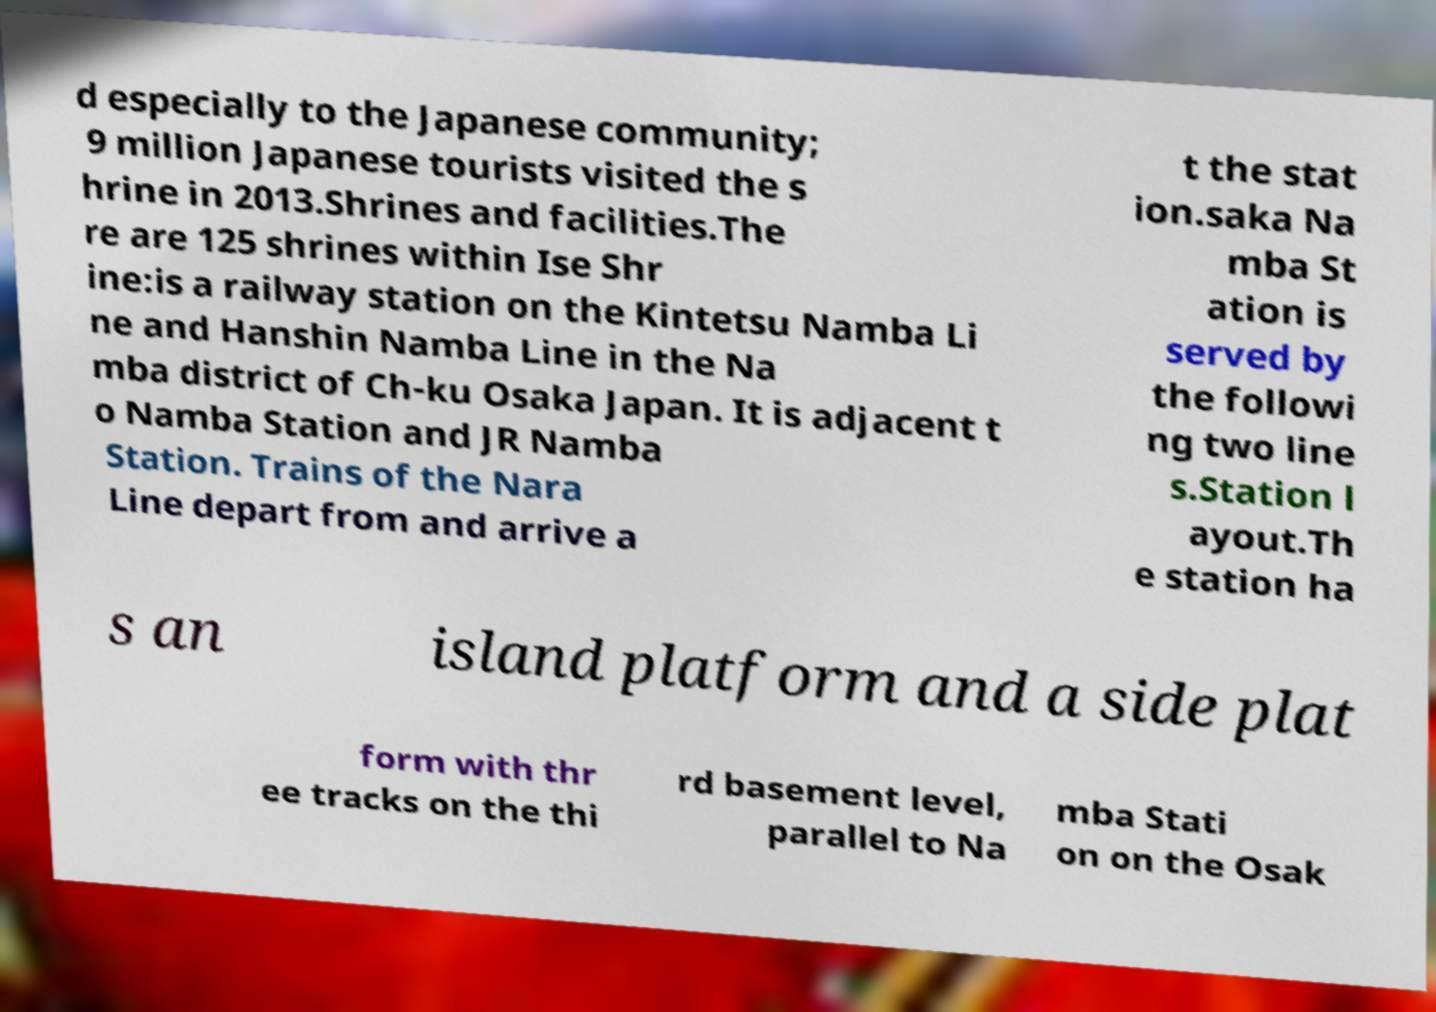I need the written content from this picture converted into text. Can you do that? d especially to the Japanese community; 9 million Japanese tourists visited the s hrine in 2013.Shrines and facilities.The re are 125 shrines within Ise Shr ine:is a railway station on the Kintetsu Namba Li ne and Hanshin Namba Line in the Na mba district of Ch-ku Osaka Japan. It is adjacent t o Namba Station and JR Namba Station. Trains of the Nara Line depart from and arrive a t the stat ion.saka Na mba St ation is served by the followi ng two line s.Station l ayout.Th e station ha s an island platform and a side plat form with thr ee tracks on the thi rd basement level, parallel to Na mba Stati on on the Osak 